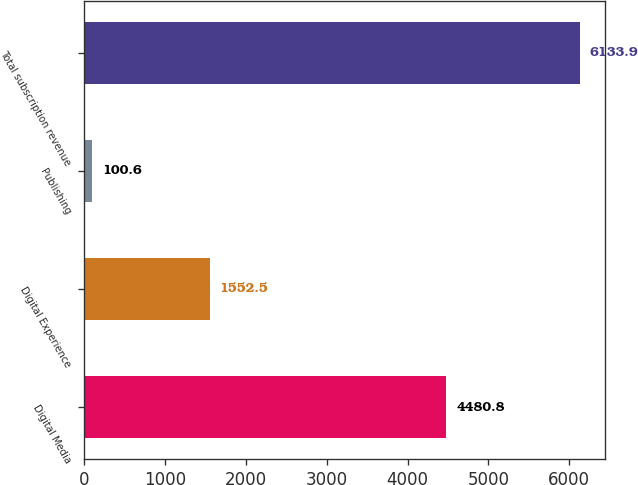Convert chart to OTSL. <chart><loc_0><loc_0><loc_500><loc_500><bar_chart><fcel>Digital Media<fcel>Digital Experience<fcel>Publishing<fcel>Total subscription revenue<nl><fcel>4480.8<fcel>1552.5<fcel>100.6<fcel>6133.9<nl></chart> 